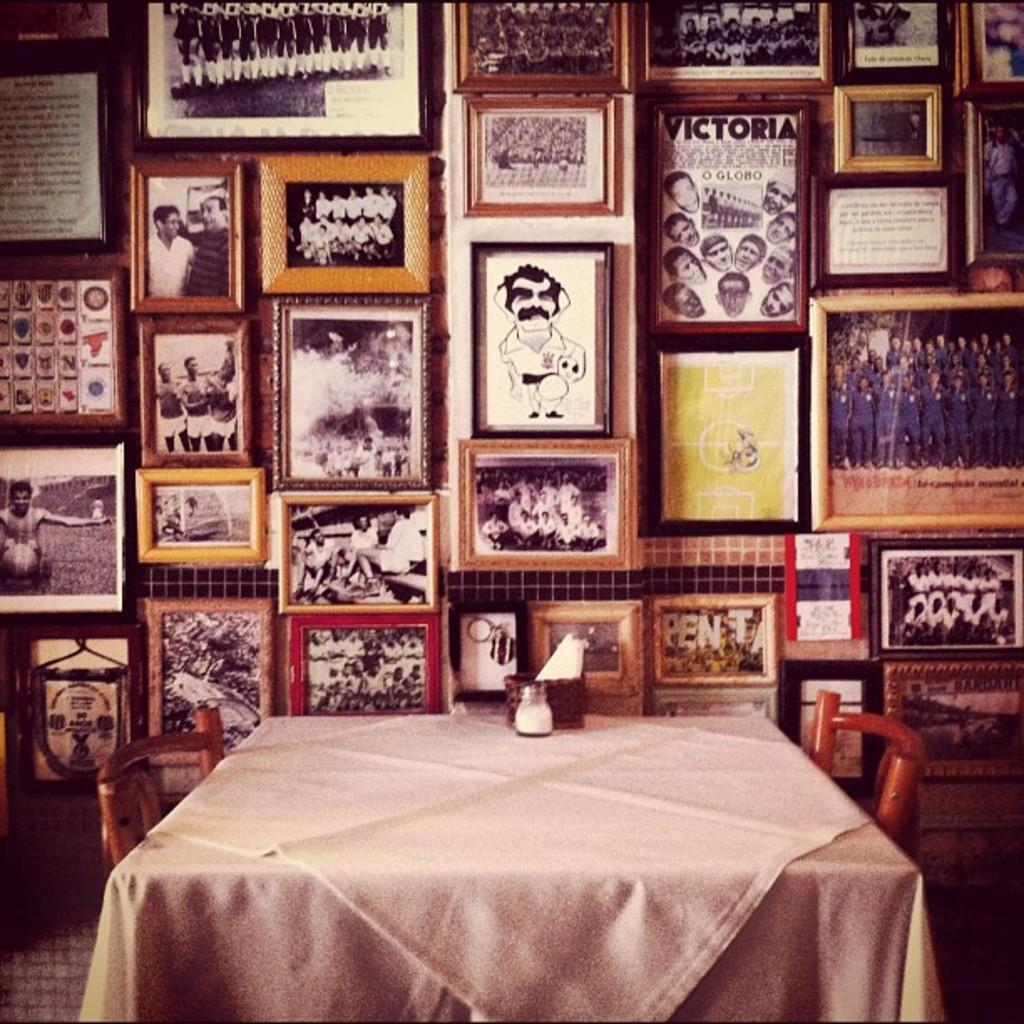What piece of furniture is present in the image? There is a table in the image. What is placed on the table? There are objects on the table. How many chairs are visible in the image? There are two chairs in the image. What type of decorative items can be seen in the image? There are many frames in the image. What type of vase is being held by the slave in the image? There is no vase or slave present in the image. 